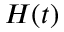<formula> <loc_0><loc_0><loc_500><loc_500>H ( t )</formula> 